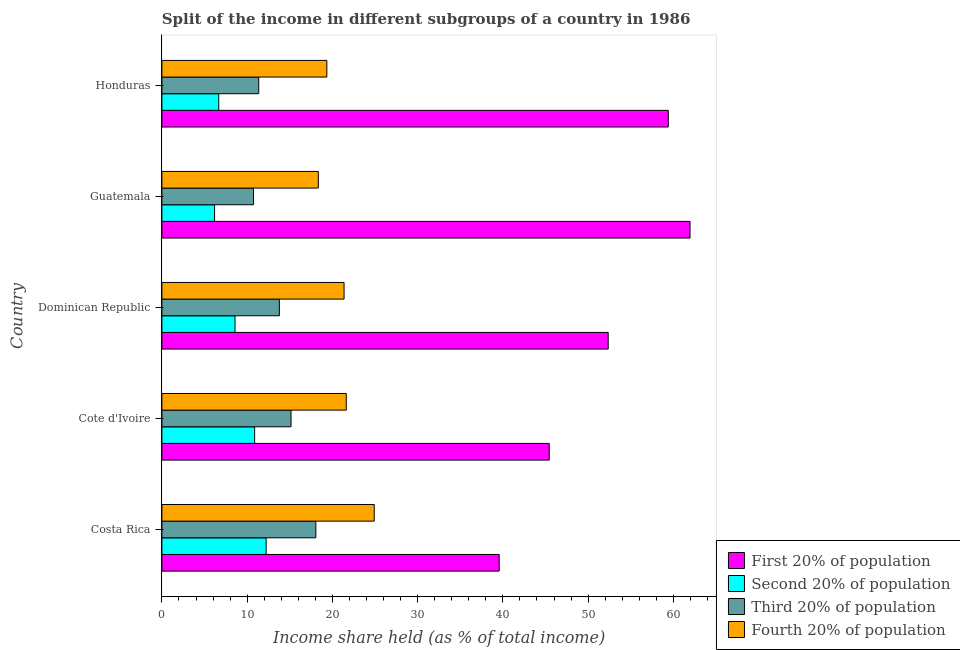How many different coloured bars are there?
Provide a short and direct response. 4. How many groups of bars are there?
Provide a succinct answer. 5. Are the number of bars on each tick of the Y-axis equal?
Your answer should be very brief. Yes. What is the label of the 3rd group of bars from the top?
Your response must be concise. Dominican Republic. In how many cases, is the number of bars for a given country not equal to the number of legend labels?
Offer a very short reply. 0. What is the share of the income held by third 20% of the population in Costa Rica?
Keep it short and to the point. 18.06. Across all countries, what is the maximum share of the income held by first 20% of the population?
Provide a short and direct response. 61.96. Across all countries, what is the minimum share of the income held by third 20% of the population?
Ensure brevity in your answer.  10.75. In which country was the share of the income held by first 20% of the population maximum?
Provide a succinct answer. Guatemala. In which country was the share of the income held by third 20% of the population minimum?
Provide a short and direct response. Guatemala. What is the total share of the income held by first 20% of the population in the graph?
Make the answer very short. 258.74. What is the difference between the share of the income held by first 20% of the population in Cote d'Ivoire and that in Dominican Republic?
Give a very brief answer. -6.92. What is the difference between the share of the income held by third 20% of the population in Guatemala and the share of the income held by first 20% of the population in Dominican Republic?
Offer a very short reply. -41.61. What is the average share of the income held by first 20% of the population per country?
Ensure brevity in your answer.  51.75. What is the difference between the share of the income held by first 20% of the population and share of the income held by fourth 20% of the population in Honduras?
Keep it short and to the point. 40.06. What is the ratio of the share of the income held by second 20% of the population in Costa Rica to that in Cote d'Ivoire?
Provide a short and direct response. 1.12. Is the share of the income held by fourth 20% of the population in Cote d'Ivoire less than that in Guatemala?
Provide a short and direct response. No. What is the difference between the highest and the second highest share of the income held by fourth 20% of the population?
Ensure brevity in your answer.  3.28. What is the difference between the highest and the lowest share of the income held by fourth 20% of the population?
Your response must be concise. 6.56. In how many countries, is the share of the income held by fourth 20% of the population greater than the average share of the income held by fourth 20% of the population taken over all countries?
Provide a succinct answer. 3. What does the 3rd bar from the top in Cote d'Ivoire represents?
Give a very brief answer. Second 20% of population. What does the 2nd bar from the bottom in Dominican Republic represents?
Your answer should be very brief. Second 20% of population. Are all the bars in the graph horizontal?
Ensure brevity in your answer.  Yes. Does the graph contain any zero values?
Make the answer very short. No. Where does the legend appear in the graph?
Your answer should be compact. Bottom right. How many legend labels are there?
Provide a succinct answer. 4. How are the legend labels stacked?
Keep it short and to the point. Vertical. What is the title of the graph?
Keep it short and to the point. Split of the income in different subgroups of a country in 1986. Does "Offering training" appear as one of the legend labels in the graph?
Provide a short and direct response. No. What is the label or title of the X-axis?
Give a very brief answer. Income share held (as % of total income). What is the label or title of the Y-axis?
Keep it short and to the point. Country. What is the Income share held (as % of total income) of First 20% of population in Costa Rica?
Provide a succinct answer. 39.57. What is the Income share held (as % of total income) in Second 20% of population in Costa Rica?
Keep it short and to the point. 12.23. What is the Income share held (as % of total income) in Third 20% of population in Costa Rica?
Offer a very short reply. 18.06. What is the Income share held (as % of total income) in Fourth 20% of population in Costa Rica?
Make the answer very short. 24.91. What is the Income share held (as % of total income) in First 20% of population in Cote d'Ivoire?
Provide a succinct answer. 45.44. What is the Income share held (as % of total income) of Second 20% of population in Cote d'Ivoire?
Provide a succinct answer. 10.88. What is the Income share held (as % of total income) in Third 20% of population in Cote d'Ivoire?
Provide a succinct answer. 15.15. What is the Income share held (as % of total income) in Fourth 20% of population in Cote d'Ivoire?
Your answer should be compact. 21.63. What is the Income share held (as % of total income) in First 20% of population in Dominican Republic?
Make the answer very short. 52.36. What is the Income share held (as % of total income) in Second 20% of population in Dominican Republic?
Offer a terse response. 8.58. What is the Income share held (as % of total income) in Third 20% of population in Dominican Republic?
Provide a short and direct response. 13.78. What is the Income share held (as % of total income) of Fourth 20% of population in Dominican Republic?
Your response must be concise. 21.37. What is the Income share held (as % of total income) in First 20% of population in Guatemala?
Make the answer very short. 61.96. What is the Income share held (as % of total income) in Second 20% of population in Guatemala?
Ensure brevity in your answer.  6.18. What is the Income share held (as % of total income) in Third 20% of population in Guatemala?
Ensure brevity in your answer.  10.75. What is the Income share held (as % of total income) of Fourth 20% of population in Guatemala?
Offer a very short reply. 18.35. What is the Income share held (as % of total income) in First 20% of population in Honduras?
Offer a terse response. 59.41. What is the Income share held (as % of total income) in Second 20% of population in Honduras?
Keep it short and to the point. 6.67. What is the Income share held (as % of total income) of Third 20% of population in Honduras?
Your answer should be compact. 11.36. What is the Income share held (as % of total income) of Fourth 20% of population in Honduras?
Provide a succinct answer. 19.35. Across all countries, what is the maximum Income share held (as % of total income) in First 20% of population?
Make the answer very short. 61.96. Across all countries, what is the maximum Income share held (as % of total income) of Second 20% of population?
Your answer should be very brief. 12.23. Across all countries, what is the maximum Income share held (as % of total income) of Third 20% of population?
Offer a very short reply. 18.06. Across all countries, what is the maximum Income share held (as % of total income) in Fourth 20% of population?
Ensure brevity in your answer.  24.91. Across all countries, what is the minimum Income share held (as % of total income) of First 20% of population?
Your answer should be very brief. 39.57. Across all countries, what is the minimum Income share held (as % of total income) of Second 20% of population?
Provide a short and direct response. 6.18. Across all countries, what is the minimum Income share held (as % of total income) in Third 20% of population?
Provide a short and direct response. 10.75. Across all countries, what is the minimum Income share held (as % of total income) in Fourth 20% of population?
Make the answer very short. 18.35. What is the total Income share held (as % of total income) in First 20% of population in the graph?
Your answer should be very brief. 258.74. What is the total Income share held (as % of total income) of Second 20% of population in the graph?
Provide a succinct answer. 44.54. What is the total Income share held (as % of total income) in Third 20% of population in the graph?
Offer a very short reply. 69.1. What is the total Income share held (as % of total income) in Fourth 20% of population in the graph?
Provide a succinct answer. 105.61. What is the difference between the Income share held (as % of total income) of First 20% of population in Costa Rica and that in Cote d'Ivoire?
Your response must be concise. -5.87. What is the difference between the Income share held (as % of total income) in Second 20% of population in Costa Rica and that in Cote d'Ivoire?
Provide a succinct answer. 1.35. What is the difference between the Income share held (as % of total income) in Third 20% of population in Costa Rica and that in Cote d'Ivoire?
Provide a short and direct response. 2.91. What is the difference between the Income share held (as % of total income) in Fourth 20% of population in Costa Rica and that in Cote d'Ivoire?
Keep it short and to the point. 3.28. What is the difference between the Income share held (as % of total income) of First 20% of population in Costa Rica and that in Dominican Republic?
Give a very brief answer. -12.79. What is the difference between the Income share held (as % of total income) in Second 20% of population in Costa Rica and that in Dominican Republic?
Give a very brief answer. 3.65. What is the difference between the Income share held (as % of total income) in Third 20% of population in Costa Rica and that in Dominican Republic?
Your response must be concise. 4.28. What is the difference between the Income share held (as % of total income) in Fourth 20% of population in Costa Rica and that in Dominican Republic?
Provide a succinct answer. 3.54. What is the difference between the Income share held (as % of total income) in First 20% of population in Costa Rica and that in Guatemala?
Your answer should be very brief. -22.39. What is the difference between the Income share held (as % of total income) of Second 20% of population in Costa Rica and that in Guatemala?
Keep it short and to the point. 6.05. What is the difference between the Income share held (as % of total income) in Third 20% of population in Costa Rica and that in Guatemala?
Offer a terse response. 7.31. What is the difference between the Income share held (as % of total income) of Fourth 20% of population in Costa Rica and that in Guatemala?
Provide a short and direct response. 6.56. What is the difference between the Income share held (as % of total income) in First 20% of population in Costa Rica and that in Honduras?
Make the answer very short. -19.84. What is the difference between the Income share held (as % of total income) in Second 20% of population in Costa Rica and that in Honduras?
Your answer should be compact. 5.56. What is the difference between the Income share held (as % of total income) in Fourth 20% of population in Costa Rica and that in Honduras?
Provide a succinct answer. 5.56. What is the difference between the Income share held (as % of total income) in First 20% of population in Cote d'Ivoire and that in Dominican Republic?
Your answer should be compact. -6.92. What is the difference between the Income share held (as % of total income) of Second 20% of population in Cote d'Ivoire and that in Dominican Republic?
Keep it short and to the point. 2.3. What is the difference between the Income share held (as % of total income) in Third 20% of population in Cote d'Ivoire and that in Dominican Republic?
Offer a terse response. 1.37. What is the difference between the Income share held (as % of total income) in Fourth 20% of population in Cote d'Ivoire and that in Dominican Republic?
Give a very brief answer. 0.26. What is the difference between the Income share held (as % of total income) in First 20% of population in Cote d'Ivoire and that in Guatemala?
Your response must be concise. -16.52. What is the difference between the Income share held (as % of total income) in Second 20% of population in Cote d'Ivoire and that in Guatemala?
Provide a succinct answer. 4.7. What is the difference between the Income share held (as % of total income) in Fourth 20% of population in Cote d'Ivoire and that in Guatemala?
Give a very brief answer. 3.28. What is the difference between the Income share held (as % of total income) of First 20% of population in Cote d'Ivoire and that in Honduras?
Make the answer very short. -13.97. What is the difference between the Income share held (as % of total income) in Second 20% of population in Cote d'Ivoire and that in Honduras?
Your answer should be compact. 4.21. What is the difference between the Income share held (as % of total income) in Third 20% of population in Cote d'Ivoire and that in Honduras?
Keep it short and to the point. 3.79. What is the difference between the Income share held (as % of total income) in Fourth 20% of population in Cote d'Ivoire and that in Honduras?
Provide a short and direct response. 2.28. What is the difference between the Income share held (as % of total income) in First 20% of population in Dominican Republic and that in Guatemala?
Your answer should be compact. -9.6. What is the difference between the Income share held (as % of total income) of Second 20% of population in Dominican Republic and that in Guatemala?
Your response must be concise. 2.4. What is the difference between the Income share held (as % of total income) of Third 20% of population in Dominican Republic and that in Guatemala?
Make the answer very short. 3.03. What is the difference between the Income share held (as % of total income) in Fourth 20% of population in Dominican Republic and that in Guatemala?
Your answer should be compact. 3.02. What is the difference between the Income share held (as % of total income) in First 20% of population in Dominican Republic and that in Honduras?
Offer a terse response. -7.05. What is the difference between the Income share held (as % of total income) of Second 20% of population in Dominican Republic and that in Honduras?
Your response must be concise. 1.91. What is the difference between the Income share held (as % of total income) of Third 20% of population in Dominican Republic and that in Honduras?
Make the answer very short. 2.42. What is the difference between the Income share held (as % of total income) of Fourth 20% of population in Dominican Republic and that in Honduras?
Give a very brief answer. 2.02. What is the difference between the Income share held (as % of total income) in First 20% of population in Guatemala and that in Honduras?
Offer a very short reply. 2.55. What is the difference between the Income share held (as % of total income) in Second 20% of population in Guatemala and that in Honduras?
Provide a succinct answer. -0.49. What is the difference between the Income share held (as % of total income) of Third 20% of population in Guatemala and that in Honduras?
Make the answer very short. -0.61. What is the difference between the Income share held (as % of total income) of Fourth 20% of population in Guatemala and that in Honduras?
Your answer should be compact. -1. What is the difference between the Income share held (as % of total income) in First 20% of population in Costa Rica and the Income share held (as % of total income) in Second 20% of population in Cote d'Ivoire?
Provide a short and direct response. 28.69. What is the difference between the Income share held (as % of total income) of First 20% of population in Costa Rica and the Income share held (as % of total income) of Third 20% of population in Cote d'Ivoire?
Keep it short and to the point. 24.42. What is the difference between the Income share held (as % of total income) in First 20% of population in Costa Rica and the Income share held (as % of total income) in Fourth 20% of population in Cote d'Ivoire?
Your answer should be very brief. 17.94. What is the difference between the Income share held (as % of total income) of Second 20% of population in Costa Rica and the Income share held (as % of total income) of Third 20% of population in Cote d'Ivoire?
Offer a terse response. -2.92. What is the difference between the Income share held (as % of total income) in Third 20% of population in Costa Rica and the Income share held (as % of total income) in Fourth 20% of population in Cote d'Ivoire?
Offer a very short reply. -3.57. What is the difference between the Income share held (as % of total income) in First 20% of population in Costa Rica and the Income share held (as % of total income) in Second 20% of population in Dominican Republic?
Your answer should be compact. 30.99. What is the difference between the Income share held (as % of total income) of First 20% of population in Costa Rica and the Income share held (as % of total income) of Third 20% of population in Dominican Republic?
Your response must be concise. 25.79. What is the difference between the Income share held (as % of total income) in Second 20% of population in Costa Rica and the Income share held (as % of total income) in Third 20% of population in Dominican Republic?
Provide a short and direct response. -1.55. What is the difference between the Income share held (as % of total income) in Second 20% of population in Costa Rica and the Income share held (as % of total income) in Fourth 20% of population in Dominican Republic?
Your response must be concise. -9.14. What is the difference between the Income share held (as % of total income) in Third 20% of population in Costa Rica and the Income share held (as % of total income) in Fourth 20% of population in Dominican Republic?
Make the answer very short. -3.31. What is the difference between the Income share held (as % of total income) of First 20% of population in Costa Rica and the Income share held (as % of total income) of Second 20% of population in Guatemala?
Your response must be concise. 33.39. What is the difference between the Income share held (as % of total income) of First 20% of population in Costa Rica and the Income share held (as % of total income) of Third 20% of population in Guatemala?
Make the answer very short. 28.82. What is the difference between the Income share held (as % of total income) in First 20% of population in Costa Rica and the Income share held (as % of total income) in Fourth 20% of population in Guatemala?
Provide a succinct answer. 21.22. What is the difference between the Income share held (as % of total income) of Second 20% of population in Costa Rica and the Income share held (as % of total income) of Third 20% of population in Guatemala?
Provide a succinct answer. 1.48. What is the difference between the Income share held (as % of total income) in Second 20% of population in Costa Rica and the Income share held (as % of total income) in Fourth 20% of population in Guatemala?
Offer a terse response. -6.12. What is the difference between the Income share held (as % of total income) in Third 20% of population in Costa Rica and the Income share held (as % of total income) in Fourth 20% of population in Guatemala?
Keep it short and to the point. -0.29. What is the difference between the Income share held (as % of total income) of First 20% of population in Costa Rica and the Income share held (as % of total income) of Second 20% of population in Honduras?
Your response must be concise. 32.9. What is the difference between the Income share held (as % of total income) in First 20% of population in Costa Rica and the Income share held (as % of total income) in Third 20% of population in Honduras?
Make the answer very short. 28.21. What is the difference between the Income share held (as % of total income) in First 20% of population in Costa Rica and the Income share held (as % of total income) in Fourth 20% of population in Honduras?
Ensure brevity in your answer.  20.22. What is the difference between the Income share held (as % of total income) in Second 20% of population in Costa Rica and the Income share held (as % of total income) in Third 20% of population in Honduras?
Your answer should be very brief. 0.87. What is the difference between the Income share held (as % of total income) of Second 20% of population in Costa Rica and the Income share held (as % of total income) of Fourth 20% of population in Honduras?
Give a very brief answer. -7.12. What is the difference between the Income share held (as % of total income) of Third 20% of population in Costa Rica and the Income share held (as % of total income) of Fourth 20% of population in Honduras?
Offer a terse response. -1.29. What is the difference between the Income share held (as % of total income) in First 20% of population in Cote d'Ivoire and the Income share held (as % of total income) in Second 20% of population in Dominican Republic?
Ensure brevity in your answer.  36.86. What is the difference between the Income share held (as % of total income) of First 20% of population in Cote d'Ivoire and the Income share held (as % of total income) of Third 20% of population in Dominican Republic?
Your response must be concise. 31.66. What is the difference between the Income share held (as % of total income) in First 20% of population in Cote d'Ivoire and the Income share held (as % of total income) in Fourth 20% of population in Dominican Republic?
Keep it short and to the point. 24.07. What is the difference between the Income share held (as % of total income) in Second 20% of population in Cote d'Ivoire and the Income share held (as % of total income) in Fourth 20% of population in Dominican Republic?
Provide a succinct answer. -10.49. What is the difference between the Income share held (as % of total income) in Third 20% of population in Cote d'Ivoire and the Income share held (as % of total income) in Fourth 20% of population in Dominican Republic?
Keep it short and to the point. -6.22. What is the difference between the Income share held (as % of total income) in First 20% of population in Cote d'Ivoire and the Income share held (as % of total income) in Second 20% of population in Guatemala?
Offer a terse response. 39.26. What is the difference between the Income share held (as % of total income) in First 20% of population in Cote d'Ivoire and the Income share held (as % of total income) in Third 20% of population in Guatemala?
Ensure brevity in your answer.  34.69. What is the difference between the Income share held (as % of total income) of First 20% of population in Cote d'Ivoire and the Income share held (as % of total income) of Fourth 20% of population in Guatemala?
Offer a very short reply. 27.09. What is the difference between the Income share held (as % of total income) in Second 20% of population in Cote d'Ivoire and the Income share held (as % of total income) in Third 20% of population in Guatemala?
Ensure brevity in your answer.  0.13. What is the difference between the Income share held (as % of total income) in Second 20% of population in Cote d'Ivoire and the Income share held (as % of total income) in Fourth 20% of population in Guatemala?
Offer a terse response. -7.47. What is the difference between the Income share held (as % of total income) in First 20% of population in Cote d'Ivoire and the Income share held (as % of total income) in Second 20% of population in Honduras?
Offer a very short reply. 38.77. What is the difference between the Income share held (as % of total income) of First 20% of population in Cote d'Ivoire and the Income share held (as % of total income) of Third 20% of population in Honduras?
Offer a very short reply. 34.08. What is the difference between the Income share held (as % of total income) of First 20% of population in Cote d'Ivoire and the Income share held (as % of total income) of Fourth 20% of population in Honduras?
Give a very brief answer. 26.09. What is the difference between the Income share held (as % of total income) in Second 20% of population in Cote d'Ivoire and the Income share held (as % of total income) in Third 20% of population in Honduras?
Provide a succinct answer. -0.48. What is the difference between the Income share held (as % of total income) in Second 20% of population in Cote d'Ivoire and the Income share held (as % of total income) in Fourth 20% of population in Honduras?
Keep it short and to the point. -8.47. What is the difference between the Income share held (as % of total income) of Third 20% of population in Cote d'Ivoire and the Income share held (as % of total income) of Fourth 20% of population in Honduras?
Your response must be concise. -4.2. What is the difference between the Income share held (as % of total income) of First 20% of population in Dominican Republic and the Income share held (as % of total income) of Second 20% of population in Guatemala?
Keep it short and to the point. 46.18. What is the difference between the Income share held (as % of total income) of First 20% of population in Dominican Republic and the Income share held (as % of total income) of Third 20% of population in Guatemala?
Your answer should be very brief. 41.61. What is the difference between the Income share held (as % of total income) in First 20% of population in Dominican Republic and the Income share held (as % of total income) in Fourth 20% of population in Guatemala?
Your answer should be very brief. 34.01. What is the difference between the Income share held (as % of total income) in Second 20% of population in Dominican Republic and the Income share held (as % of total income) in Third 20% of population in Guatemala?
Make the answer very short. -2.17. What is the difference between the Income share held (as % of total income) of Second 20% of population in Dominican Republic and the Income share held (as % of total income) of Fourth 20% of population in Guatemala?
Provide a short and direct response. -9.77. What is the difference between the Income share held (as % of total income) in Third 20% of population in Dominican Republic and the Income share held (as % of total income) in Fourth 20% of population in Guatemala?
Keep it short and to the point. -4.57. What is the difference between the Income share held (as % of total income) in First 20% of population in Dominican Republic and the Income share held (as % of total income) in Second 20% of population in Honduras?
Make the answer very short. 45.69. What is the difference between the Income share held (as % of total income) in First 20% of population in Dominican Republic and the Income share held (as % of total income) in Fourth 20% of population in Honduras?
Your response must be concise. 33.01. What is the difference between the Income share held (as % of total income) in Second 20% of population in Dominican Republic and the Income share held (as % of total income) in Third 20% of population in Honduras?
Your answer should be very brief. -2.78. What is the difference between the Income share held (as % of total income) of Second 20% of population in Dominican Republic and the Income share held (as % of total income) of Fourth 20% of population in Honduras?
Provide a succinct answer. -10.77. What is the difference between the Income share held (as % of total income) of Third 20% of population in Dominican Republic and the Income share held (as % of total income) of Fourth 20% of population in Honduras?
Provide a succinct answer. -5.57. What is the difference between the Income share held (as % of total income) of First 20% of population in Guatemala and the Income share held (as % of total income) of Second 20% of population in Honduras?
Make the answer very short. 55.29. What is the difference between the Income share held (as % of total income) in First 20% of population in Guatemala and the Income share held (as % of total income) in Third 20% of population in Honduras?
Keep it short and to the point. 50.6. What is the difference between the Income share held (as % of total income) of First 20% of population in Guatemala and the Income share held (as % of total income) of Fourth 20% of population in Honduras?
Your answer should be very brief. 42.61. What is the difference between the Income share held (as % of total income) of Second 20% of population in Guatemala and the Income share held (as % of total income) of Third 20% of population in Honduras?
Provide a succinct answer. -5.18. What is the difference between the Income share held (as % of total income) in Second 20% of population in Guatemala and the Income share held (as % of total income) in Fourth 20% of population in Honduras?
Provide a short and direct response. -13.17. What is the difference between the Income share held (as % of total income) of Third 20% of population in Guatemala and the Income share held (as % of total income) of Fourth 20% of population in Honduras?
Offer a very short reply. -8.6. What is the average Income share held (as % of total income) in First 20% of population per country?
Offer a terse response. 51.75. What is the average Income share held (as % of total income) of Second 20% of population per country?
Make the answer very short. 8.91. What is the average Income share held (as % of total income) of Third 20% of population per country?
Your answer should be compact. 13.82. What is the average Income share held (as % of total income) of Fourth 20% of population per country?
Keep it short and to the point. 21.12. What is the difference between the Income share held (as % of total income) of First 20% of population and Income share held (as % of total income) of Second 20% of population in Costa Rica?
Offer a very short reply. 27.34. What is the difference between the Income share held (as % of total income) in First 20% of population and Income share held (as % of total income) in Third 20% of population in Costa Rica?
Provide a succinct answer. 21.51. What is the difference between the Income share held (as % of total income) in First 20% of population and Income share held (as % of total income) in Fourth 20% of population in Costa Rica?
Your answer should be compact. 14.66. What is the difference between the Income share held (as % of total income) of Second 20% of population and Income share held (as % of total income) of Third 20% of population in Costa Rica?
Your answer should be compact. -5.83. What is the difference between the Income share held (as % of total income) of Second 20% of population and Income share held (as % of total income) of Fourth 20% of population in Costa Rica?
Provide a short and direct response. -12.68. What is the difference between the Income share held (as % of total income) of Third 20% of population and Income share held (as % of total income) of Fourth 20% of population in Costa Rica?
Provide a succinct answer. -6.85. What is the difference between the Income share held (as % of total income) in First 20% of population and Income share held (as % of total income) in Second 20% of population in Cote d'Ivoire?
Give a very brief answer. 34.56. What is the difference between the Income share held (as % of total income) of First 20% of population and Income share held (as % of total income) of Third 20% of population in Cote d'Ivoire?
Offer a very short reply. 30.29. What is the difference between the Income share held (as % of total income) in First 20% of population and Income share held (as % of total income) in Fourth 20% of population in Cote d'Ivoire?
Provide a short and direct response. 23.81. What is the difference between the Income share held (as % of total income) of Second 20% of population and Income share held (as % of total income) of Third 20% of population in Cote d'Ivoire?
Provide a succinct answer. -4.27. What is the difference between the Income share held (as % of total income) in Second 20% of population and Income share held (as % of total income) in Fourth 20% of population in Cote d'Ivoire?
Offer a terse response. -10.75. What is the difference between the Income share held (as % of total income) in Third 20% of population and Income share held (as % of total income) in Fourth 20% of population in Cote d'Ivoire?
Give a very brief answer. -6.48. What is the difference between the Income share held (as % of total income) in First 20% of population and Income share held (as % of total income) in Second 20% of population in Dominican Republic?
Ensure brevity in your answer.  43.78. What is the difference between the Income share held (as % of total income) of First 20% of population and Income share held (as % of total income) of Third 20% of population in Dominican Republic?
Make the answer very short. 38.58. What is the difference between the Income share held (as % of total income) of First 20% of population and Income share held (as % of total income) of Fourth 20% of population in Dominican Republic?
Your answer should be very brief. 30.99. What is the difference between the Income share held (as % of total income) in Second 20% of population and Income share held (as % of total income) in Fourth 20% of population in Dominican Republic?
Provide a short and direct response. -12.79. What is the difference between the Income share held (as % of total income) of Third 20% of population and Income share held (as % of total income) of Fourth 20% of population in Dominican Republic?
Provide a succinct answer. -7.59. What is the difference between the Income share held (as % of total income) in First 20% of population and Income share held (as % of total income) in Second 20% of population in Guatemala?
Give a very brief answer. 55.78. What is the difference between the Income share held (as % of total income) of First 20% of population and Income share held (as % of total income) of Third 20% of population in Guatemala?
Ensure brevity in your answer.  51.21. What is the difference between the Income share held (as % of total income) of First 20% of population and Income share held (as % of total income) of Fourth 20% of population in Guatemala?
Keep it short and to the point. 43.61. What is the difference between the Income share held (as % of total income) of Second 20% of population and Income share held (as % of total income) of Third 20% of population in Guatemala?
Keep it short and to the point. -4.57. What is the difference between the Income share held (as % of total income) of Second 20% of population and Income share held (as % of total income) of Fourth 20% of population in Guatemala?
Provide a succinct answer. -12.17. What is the difference between the Income share held (as % of total income) in First 20% of population and Income share held (as % of total income) in Second 20% of population in Honduras?
Keep it short and to the point. 52.74. What is the difference between the Income share held (as % of total income) of First 20% of population and Income share held (as % of total income) of Third 20% of population in Honduras?
Make the answer very short. 48.05. What is the difference between the Income share held (as % of total income) in First 20% of population and Income share held (as % of total income) in Fourth 20% of population in Honduras?
Your response must be concise. 40.06. What is the difference between the Income share held (as % of total income) in Second 20% of population and Income share held (as % of total income) in Third 20% of population in Honduras?
Keep it short and to the point. -4.69. What is the difference between the Income share held (as % of total income) of Second 20% of population and Income share held (as % of total income) of Fourth 20% of population in Honduras?
Provide a succinct answer. -12.68. What is the difference between the Income share held (as % of total income) of Third 20% of population and Income share held (as % of total income) of Fourth 20% of population in Honduras?
Give a very brief answer. -7.99. What is the ratio of the Income share held (as % of total income) in First 20% of population in Costa Rica to that in Cote d'Ivoire?
Your response must be concise. 0.87. What is the ratio of the Income share held (as % of total income) in Second 20% of population in Costa Rica to that in Cote d'Ivoire?
Ensure brevity in your answer.  1.12. What is the ratio of the Income share held (as % of total income) in Third 20% of population in Costa Rica to that in Cote d'Ivoire?
Make the answer very short. 1.19. What is the ratio of the Income share held (as % of total income) in Fourth 20% of population in Costa Rica to that in Cote d'Ivoire?
Make the answer very short. 1.15. What is the ratio of the Income share held (as % of total income) of First 20% of population in Costa Rica to that in Dominican Republic?
Provide a short and direct response. 0.76. What is the ratio of the Income share held (as % of total income) in Second 20% of population in Costa Rica to that in Dominican Republic?
Keep it short and to the point. 1.43. What is the ratio of the Income share held (as % of total income) in Third 20% of population in Costa Rica to that in Dominican Republic?
Offer a very short reply. 1.31. What is the ratio of the Income share held (as % of total income) in Fourth 20% of population in Costa Rica to that in Dominican Republic?
Provide a short and direct response. 1.17. What is the ratio of the Income share held (as % of total income) of First 20% of population in Costa Rica to that in Guatemala?
Your answer should be compact. 0.64. What is the ratio of the Income share held (as % of total income) in Second 20% of population in Costa Rica to that in Guatemala?
Give a very brief answer. 1.98. What is the ratio of the Income share held (as % of total income) of Third 20% of population in Costa Rica to that in Guatemala?
Offer a very short reply. 1.68. What is the ratio of the Income share held (as % of total income) of Fourth 20% of population in Costa Rica to that in Guatemala?
Keep it short and to the point. 1.36. What is the ratio of the Income share held (as % of total income) of First 20% of population in Costa Rica to that in Honduras?
Offer a terse response. 0.67. What is the ratio of the Income share held (as % of total income) of Second 20% of population in Costa Rica to that in Honduras?
Give a very brief answer. 1.83. What is the ratio of the Income share held (as % of total income) in Third 20% of population in Costa Rica to that in Honduras?
Your answer should be compact. 1.59. What is the ratio of the Income share held (as % of total income) in Fourth 20% of population in Costa Rica to that in Honduras?
Make the answer very short. 1.29. What is the ratio of the Income share held (as % of total income) of First 20% of population in Cote d'Ivoire to that in Dominican Republic?
Provide a succinct answer. 0.87. What is the ratio of the Income share held (as % of total income) of Second 20% of population in Cote d'Ivoire to that in Dominican Republic?
Offer a terse response. 1.27. What is the ratio of the Income share held (as % of total income) of Third 20% of population in Cote d'Ivoire to that in Dominican Republic?
Your answer should be very brief. 1.1. What is the ratio of the Income share held (as % of total income) in Fourth 20% of population in Cote d'Ivoire to that in Dominican Republic?
Ensure brevity in your answer.  1.01. What is the ratio of the Income share held (as % of total income) of First 20% of population in Cote d'Ivoire to that in Guatemala?
Your answer should be compact. 0.73. What is the ratio of the Income share held (as % of total income) in Second 20% of population in Cote d'Ivoire to that in Guatemala?
Your response must be concise. 1.76. What is the ratio of the Income share held (as % of total income) of Third 20% of population in Cote d'Ivoire to that in Guatemala?
Offer a very short reply. 1.41. What is the ratio of the Income share held (as % of total income) of Fourth 20% of population in Cote d'Ivoire to that in Guatemala?
Your response must be concise. 1.18. What is the ratio of the Income share held (as % of total income) of First 20% of population in Cote d'Ivoire to that in Honduras?
Make the answer very short. 0.76. What is the ratio of the Income share held (as % of total income) in Second 20% of population in Cote d'Ivoire to that in Honduras?
Ensure brevity in your answer.  1.63. What is the ratio of the Income share held (as % of total income) of Third 20% of population in Cote d'Ivoire to that in Honduras?
Your answer should be very brief. 1.33. What is the ratio of the Income share held (as % of total income) of Fourth 20% of population in Cote d'Ivoire to that in Honduras?
Offer a very short reply. 1.12. What is the ratio of the Income share held (as % of total income) in First 20% of population in Dominican Republic to that in Guatemala?
Make the answer very short. 0.85. What is the ratio of the Income share held (as % of total income) of Second 20% of population in Dominican Republic to that in Guatemala?
Offer a terse response. 1.39. What is the ratio of the Income share held (as % of total income) in Third 20% of population in Dominican Republic to that in Guatemala?
Make the answer very short. 1.28. What is the ratio of the Income share held (as % of total income) of Fourth 20% of population in Dominican Republic to that in Guatemala?
Offer a terse response. 1.16. What is the ratio of the Income share held (as % of total income) in First 20% of population in Dominican Republic to that in Honduras?
Ensure brevity in your answer.  0.88. What is the ratio of the Income share held (as % of total income) of Second 20% of population in Dominican Republic to that in Honduras?
Give a very brief answer. 1.29. What is the ratio of the Income share held (as % of total income) of Third 20% of population in Dominican Republic to that in Honduras?
Your response must be concise. 1.21. What is the ratio of the Income share held (as % of total income) of Fourth 20% of population in Dominican Republic to that in Honduras?
Your answer should be very brief. 1.1. What is the ratio of the Income share held (as % of total income) of First 20% of population in Guatemala to that in Honduras?
Ensure brevity in your answer.  1.04. What is the ratio of the Income share held (as % of total income) of Second 20% of population in Guatemala to that in Honduras?
Offer a terse response. 0.93. What is the ratio of the Income share held (as % of total income) of Third 20% of population in Guatemala to that in Honduras?
Your answer should be compact. 0.95. What is the ratio of the Income share held (as % of total income) of Fourth 20% of population in Guatemala to that in Honduras?
Provide a succinct answer. 0.95. What is the difference between the highest and the second highest Income share held (as % of total income) of First 20% of population?
Keep it short and to the point. 2.55. What is the difference between the highest and the second highest Income share held (as % of total income) of Second 20% of population?
Offer a terse response. 1.35. What is the difference between the highest and the second highest Income share held (as % of total income) of Third 20% of population?
Provide a short and direct response. 2.91. What is the difference between the highest and the second highest Income share held (as % of total income) in Fourth 20% of population?
Make the answer very short. 3.28. What is the difference between the highest and the lowest Income share held (as % of total income) of First 20% of population?
Offer a very short reply. 22.39. What is the difference between the highest and the lowest Income share held (as % of total income) of Second 20% of population?
Offer a terse response. 6.05. What is the difference between the highest and the lowest Income share held (as % of total income) in Third 20% of population?
Offer a very short reply. 7.31. What is the difference between the highest and the lowest Income share held (as % of total income) of Fourth 20% of population?
Keep it short and to the point. 6.56. 